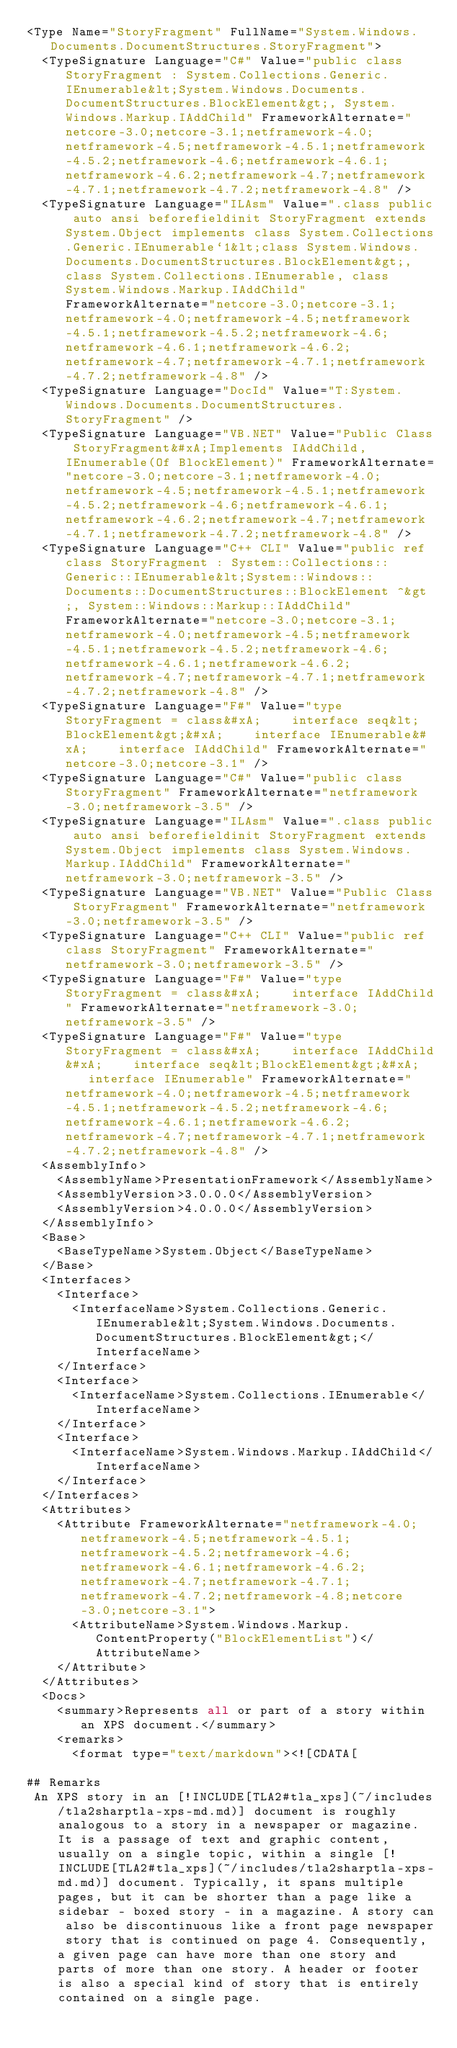<code> <loc_0><loc_0><loc_500><loc_500><_XML_><Type Name="StoryFragment" FullName="System.Windows.Documents.DocumentStructures.StoryFragment">
  <TypeSignature Language="C#" Value="public class StoryFragment : System.Collections.Generic.IEnumerable&lt;System.Windows.Documents.DocumentStructures.BlockElement&gt;, System.Windows.Markup.IAddChild" FrameworkAlternate="netcore-3.0;netcore-3.1;netframework-4.0;netframework-4.5;netframework-4.5.1;netframework-4.5.2;netframework-4.6;netframework-4.6.1;netframework-4.6.2;netframework-4.7;netframework-4.7.1;netframework-4.7.2;netframework-4.8" />
  <TypeSignature Language="ILAsm" Value=".class public auto ansi beforefieldinit StoryFragment extends System.Object implements class System.Collections.Generic.IEnumerable`1&lt;class System.Windows.Documents.DocumentStructures.BlockElement&gt;, class System.Collections.IEnumerable, class System.Windows.Markup.IAddChild" FrameworkAlternate="netcore-3.0;netcore-3.1;netframework-4.0;netframework-4.5;netframework-4.5.1;netframework-4.5.2;netframework-4.6;netframework-4.6.1;netframework-4.6.2;netframework-4.7;netframework-4.7.1;netframework-4.7.2;netframework-4.8" />
  <TypeSignature Language="DocId" Value="T:System.Windows.Documents.DocumentStructures.StoryFragment" />
  <TypeSignature Language="VB.NET" Value="Public Class StoryFragment&#xA;Implements IAddChild, IEnumerable(Of BlockElement)" FrameworkAlternate="netcore-3.0;netcore-3.1;netframework-4.0;netframework-4.5;netframework-4.5.1;netframework-4.5.2;netframework-4.6;netframework-4.6.1;netframework-4.6.2;netframework-4.7;netframework-4.7.1;netframework-4.7.2;netframework-4.8" />
  <TypeSignature Language="C++ CLI" Value="public ref class StoryFragment : System::Collections::Generic::IEnumerable&lt;System::Windows::Documents::DocumentStructures::BlockElement ^&gt;, System::Windows::Markup::IAddChild" FrameworkAlternate="netcore-3.0;netcore-3.1;netframework-4.0;netframework-4.5;netframework-4.5.1;netframework-4.5.2;netframework-4.6;netframework-4.6.1;netframework-4.6.2;netframework-4.7;netframework-4.7.1;netframework-4.7.2;netframework-4.8" />
  <TypeSignature Language="F#" Value="type StoryFragment = class&#xA;    interface seq&lt;BlockElement&gt;&#xA;    interface IEnumerable&#xA;    interface IAddChild" FrameworkAlternate="netcore-3.0;netcore-3.1" />
  <TypeSignature Language="C#" Value="public class StoryFragment" FrameworkAlternate="netframework-3.0;netframework-3.5" />
  <TypeSignature Language="ILAsm" Value=".class public auto ansi beforefieldinit StoryFragment extends System.Object implements class System.Windows.Markup.IAddChild" FrameworkAlternate="netframework-3.0;netframework-3.5" />
  <TypeSignature Language="VB.NET" Value="Public Class StoryFragment" FrameworkAlternate="netframework-3.0;netframework-3.5" />
  <TypeSignature Language="C++ CLI" Value="public ref class StoryFragment" FrameworkAlternate="netframework-3.0;netframework-3.5" />
  <TypeSignature Language="F#" Value="type StoryFragment = class&#xA;    interface IAddChild" FrameworkAlternate="netframework-3.0;netframework-3.5" />
  <TypeSignature Language="F#" Value="type StoryFragment = class&#xA;    interface IAddChild&#xA;    interface seq&lt;BlockElement&gt;&#xA;    interface IEnumerable" FrameworkAlternate="netframework-4.0;netframework-4.5;netframework-4.5.1;netframework-4.5.2;netframework-4.6;netframework-4.6.1;netframework-4.6.2;netframework-4.7;netframework-4.7.1;netframework-4.7.2;netframework-4.8" />
  <AssemblyInfo>
    <AssemblyName>PresentationFramework</AssemblyName>
    <AssemblyVersion>3.0.0.0</AssemblyVersion>
    <AssemblyVersion>4.0.0.0</AssemblyVersion>
  </AssemblyInfo>
  <Base>
    <BaseTypeName>System.Object</BaseTypeName>
  </Base>
  <Interfaces>
    <Interface>
      <InterfaceName>System.Collections.Generic.IEnumerable&lt;System.Windows.Documents.DocumentStructures.BlockElement&gt;</InterfaceName>
    </Interface>
    <Interface>
      <InterfaceName>System.Collections.IEnumerable</InterfaceName>
    </Interface>
    <Interface>
      <InterfaceName>System.Windows.Markup.IAddChild</InterfaceName>
    </Interface>
  </Interfaces>
  <Attributes>
    <Attribute FrameworkAlternate="netframework-4.0;netframework-4.5;netframework-4.5.1;netframework-4.5.2;netframework-4.6;netframework-4.6.1;netframework-4.6.2;netframework-4.7;netframework-4.7.1;netframework-4.7.2;netframework-4.8;netcore-3.0;netcore-3.1">
      <AttributeName>System.Windows.Markup.ContentProperty("BlockElementList")</AttributeName>
    </Attribute>
  </Attributes>
  <Docs>
    <summary>Represents all or part of a story within an XPS document.</summary>
    <remarks>
      <format type="text/markdown"><![CDATA[  
  
## Remarks  
 An XPS story in an [!INCLUDE[TLA2#tla_xps](~/includes/tla2sharptla-xps-md.md)] document is roughly analogous to a story in a newspaper or magazine. It is a passage of text and graphic content, usually on a single topic, within a single [!INCLUDE[TLA2#tla_xps](~/includes/tla2sharptla-xps-md.md)] document. Typically, it spans multiple pages, but it can be shorter than a page like a sidebar - boxed story - in a magazine. A story can also be discontinuous like a front page newspaper story that is continued on page 4. Consequently, a given page can have more than one story and parts of more than one story. A header or footer is also a special kind of story that is entirely contained on a single page.  
  </code> 